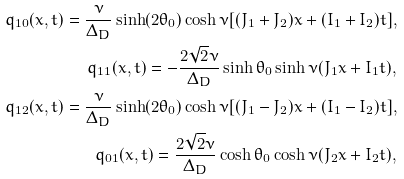<formula> <loc_0><loc_0><loc_500><loc_500>q _ { 1 0 } ( x , t ) = \frac { \nu } { \Delta _ { D } } \sinh ( 2 \theta _ { 0 } ) \cosh \nu [ ( J _ { 1 } + J _ { 2 } ) x + ( I _ { 1 } + I _ { 2 } ) t ] , \\ q _ { 1 1 } ( x , t ) = - \frac { 2 \sqrt { 2 } \nu } { \Delta _ { D } } \sinh \theta _ { 0 } \sinh \nu ( J _ { 1 } x + I _ { 1 } t ) , \\ q _ { 1 2 } ( x , t ) = \frac { \nu } { \Delta _ { D } } \sinh ( 2 \theta _ { 0 } ) \cosh \nu [ ( J _ { 1 } - J _ { 2 } ) x + ( I _ { 1 } - I _ { 2 } ) t ] , \\ q _ { 0 1 } ( x , t ) = \frac { 2 \sqrt { 2 } \nu } { \Delta _ { D } } \cosh \theta _ { 0 } \cosh \nu ( J _ { 2 } x + I _ { 2 } t ) ,</formula> 